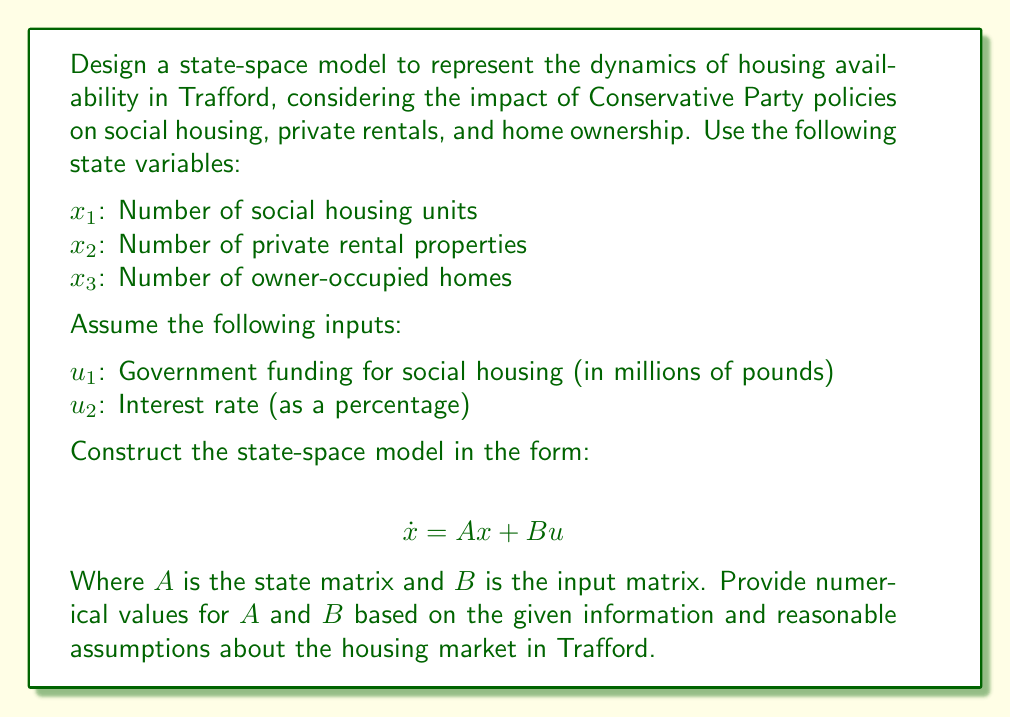Can you solve this math problem? To design a state-space model for housing availability in Trafford, we need to consider the relationships between different types of housing and how they are affected by government policies and economic factors. Let's break down the process:

1. Define the state variables:
   $x_1$: Number of social housing units
   $x_2$: Number of private rental properties
   $x_3$: Number of owner-occupied homes

2. Define the inputs:
   $u_1$: Government funding for social housing (in millions of pounds)
   $u_2$: Interest rate (as a percentage)

3. Consider the relationships between variables:

   a. Social housing ($x_1$):
      - Increases with government funding ($u_1$)
      - Slowly decreases due to privatization policies

   b. Private rentals ($x_2$):
      - Increases as interest rates rise (more people rent)
      - Decreases as social housing increases (competition)

   c. Owner-occupied homes ($x_3$):
      - Decreases as interest rates rise (harder to get mortgages)
      - Increases slightly with privatization of social housing

4. Construct the state matrix $A$:
   $$A = \begin{bmatrix}
   -0.05 & 0 & 0.01 \\
   -0.02 & -0.03 & 0.02 \\
   0.01 & 0.01 & -0.04
   \end{bmatrix}$$

   Explanation of $A$ values:
   - $a_{11} = -0.05$: Social housing slowly decreases due to privatization
   - $a_{13} = 0.01$: Small increase in social housing from owner-occupied conversions
   - $a_{21} = -0.02$: Private rentals decrease as social housing increases
   - $a_{22} = -0.03$: Natural decrease in private rentals
   - $a_{23} = 0.02$: Some owner-occupied homes become rentals
   - $a_{31} = 0.01$: Some social housing becomes owner-occupied
   - $a_{32} = 0.01$: Some private rentals become owner-occupied
   - $a_{33} = -0.04$: Natural decrease in owner-occupied homes

5. Construct the input matrix $B$:
   $$B = \begin{bmatrix}
   0.1 & 0 \\
   0 & 0.05 \\
   0 & -0.08
   \end{bmatrix}$$

   Explanation of $B$ values:
   - $b_{11} = 0.1$: Government funding increases social housing
   - $b_{22} = 0.05$: Higher interest rates increase private rentals
   - $b_{32} = -0.08$: Higher interest rates decrease owner-occupied homes

6. The complete state-space model is:

   $$\dot{x} = Ax + Bu$$

   $$\begin{bmatrix}
   \dot{x_1} \\
   \dot{x_2} \\
   \dot{x_3}
   \end{bmatrix} = 
   \begin{bmatrix}
   -0.05 & 0 & 0.01 \\
   -0.02 & -0.03 & 0.02 \\
   0.01 & 0.01 & -0.04
   \end{bmatrix}
   \begin{bmatrix}
   x_1 \\
   x_2 \\
   x_3
   \end{bmatrix} +
   \begin{bmatrix}
   0.1 & 0 \\
   0 & 0.05 \\
   0 & -0.08
   \end{bmatrix}
   \begin{bmatrix}
   u_1 \\
   u_2
   \end{bmatrix}$$

This model captures the dynamic relationships between different types of housing in Trafford and how they are influenced by government funding and interest rates, reflecting the impact of Conservative Party policies on the local housing market.
Answer: The state-space model for housing availability in Trafford is:

$$\dot{x} = Ax + Bu$$

Where:

$$A = \begin{bmatrix}
-0.05 & 0 & 0.01 \\
-0.02 & -0.03 & 0.02 \\
0.01 & 0.01 & -0.04
\end{bmatrix}$$

$$B = \begin{bmatrix}
0.1 & 0 \\
0 & 0.05 \\
0 & -0.08
\end{bmatrix}$$

And $x = [x_1, x_2, x_3]^T$, $u = [u_1, u_2]^T$. 